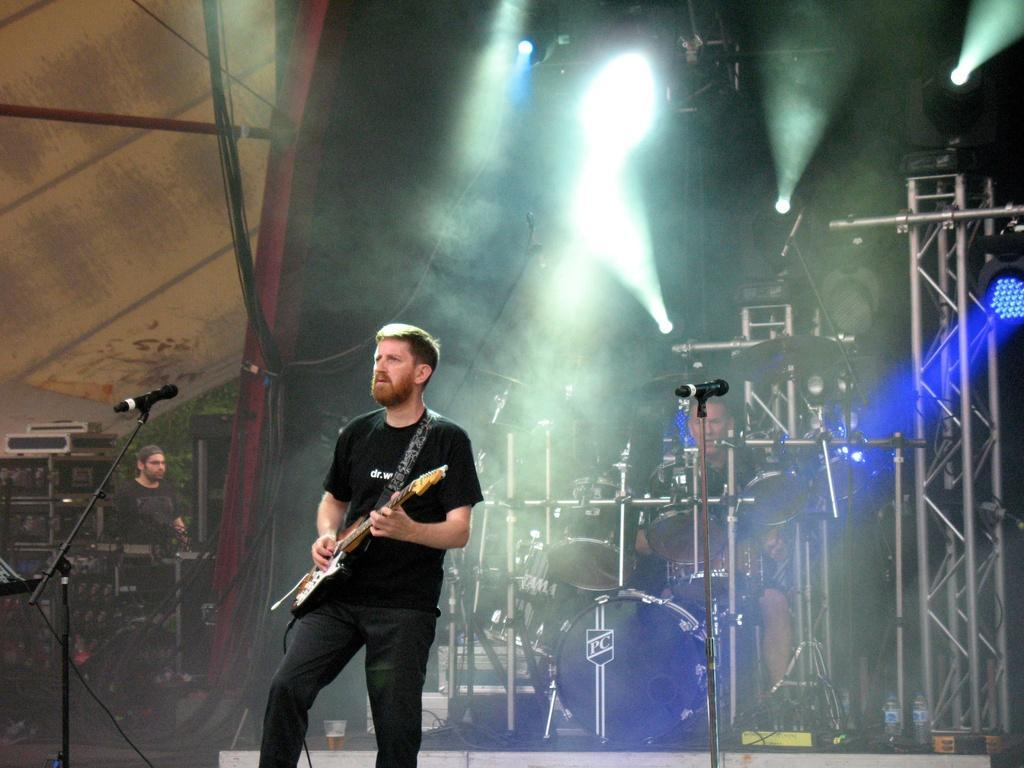In one or two sentences, can you explain what this image depicts? In this image we can see a man standing in the center and he is playing a guitar. In the background we can see a man playing a snare drum and there is a lighting arrangement. 